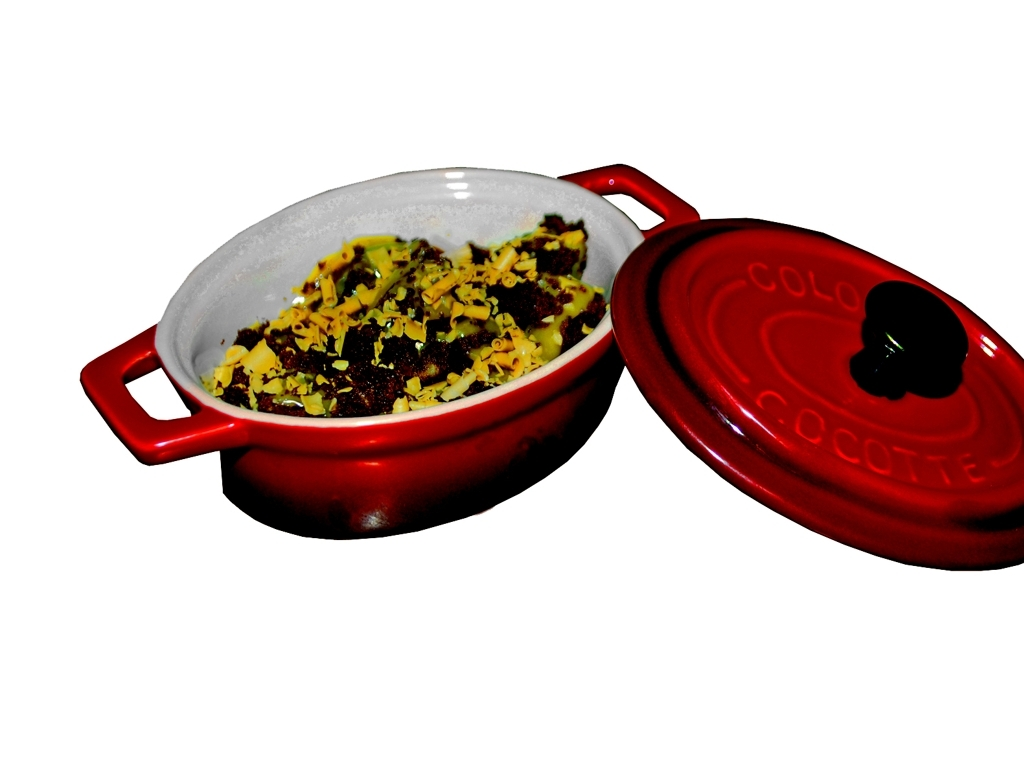What colors are present in the image? The image features a dish with a mixture of yellow, green, and brown colors, indicating different ingredients. These colors appear vibrant against the white interior of the red dish, which adds a pop of brightness and contrast to the scene. 